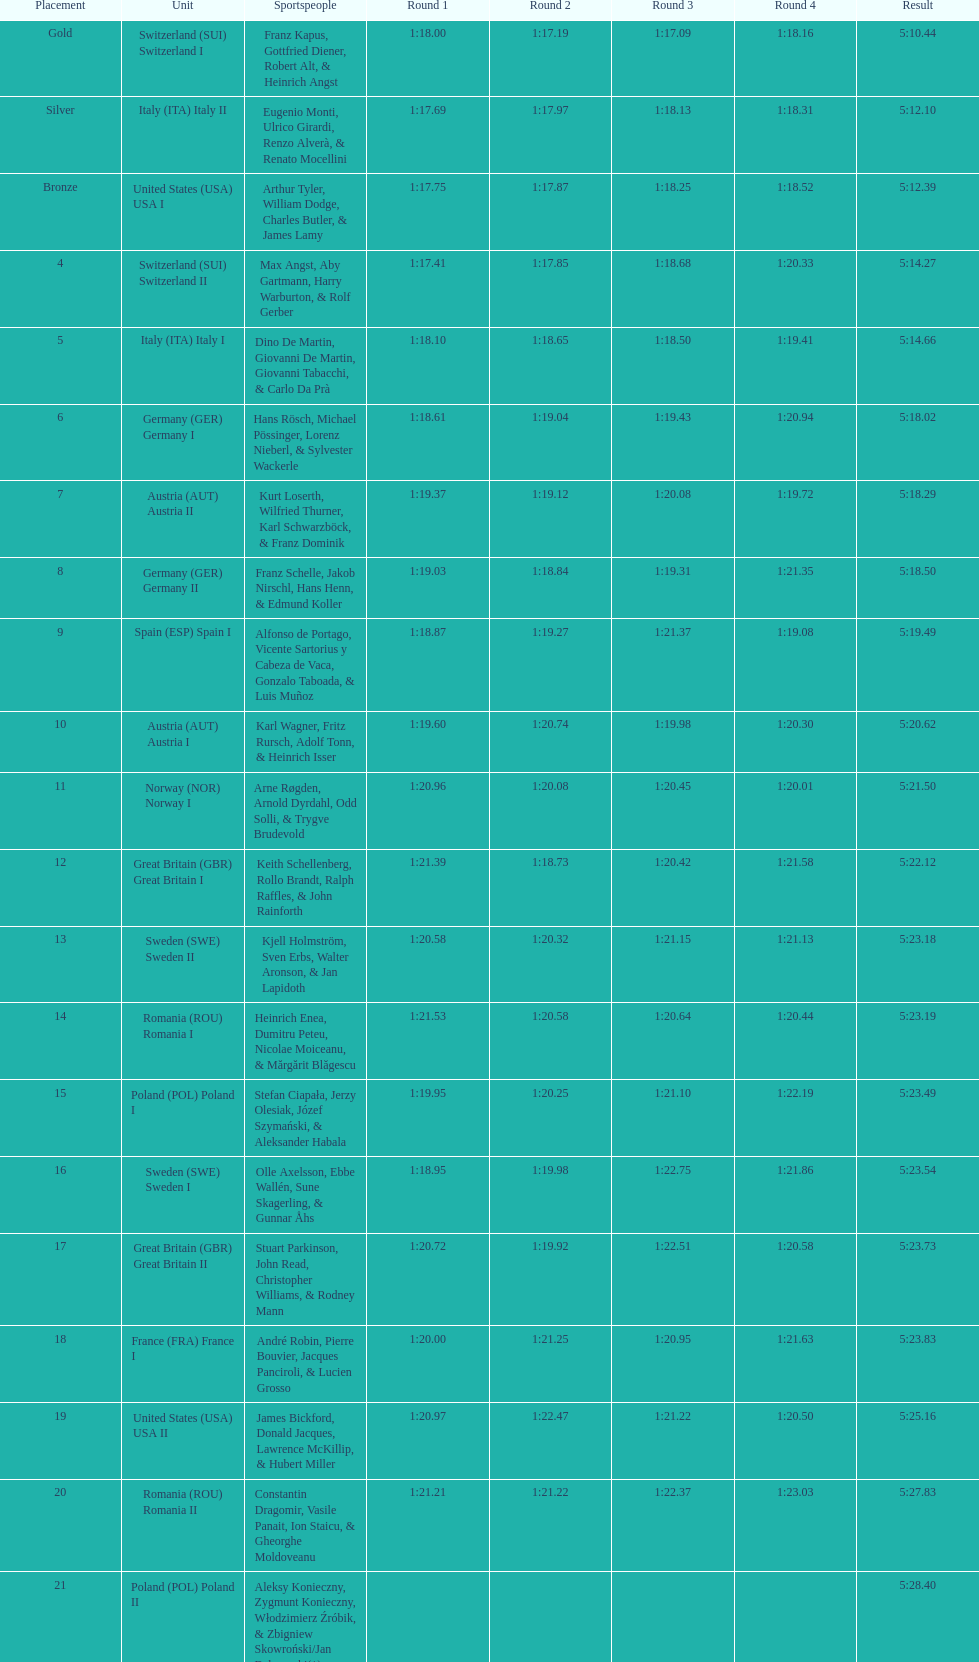After italy (ita) italy i, what team comes next? Germany I. 